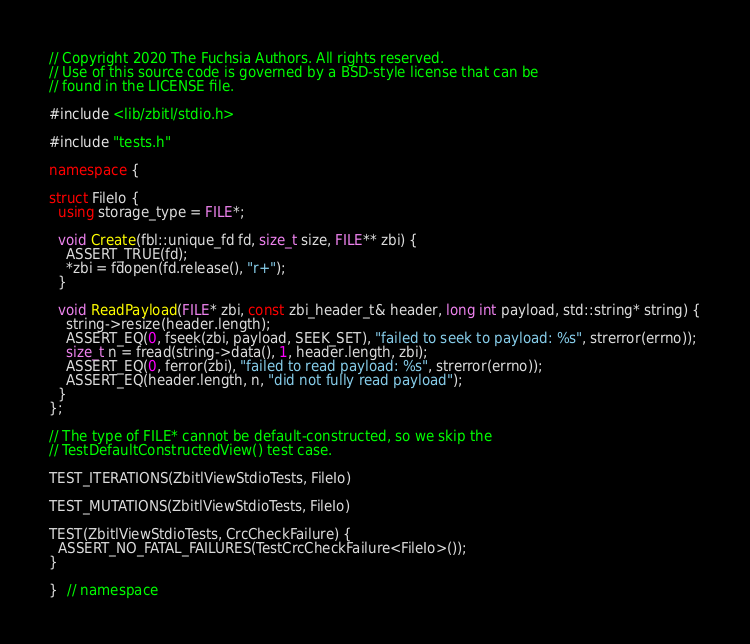<code> <loc_0><loc_0><loc_500><loc_500><_C++_>// Copyright 2020 The Fuchsia Authors. All rights reserved.
// Use of this source code is governed by a BSD-style license that can be
// found in the LICENSE file.

#include <lib/zbitl/stdio.h>

#include "tests.h"

namespace {

struct FileIo {
  using storage_type = FILE*;

  void Create(fbl::unique_fd fd, size_t size, FILE** zbi) {
    ASSERT_TRUE(fd);
    *zbi = fdopen(fd.release(), "r+");
  }

  void ReadPayload(FILE* zbi, const zbi_header_t& header, long int payload, std::string* string) {
    string->resize(header.length);
    ASSERT_EQ(0, fseek(zbi, payload, SEEK_SET), "failed to seek to payload: %s", strerror(errno));
    size_t n = fread(string->data(), 1, header.length, zbi);
    ASSERT_EQ(0, ferror(zbi), "failed to read payload: %s", strerror(errno));
    ASSERT_EQ(header.length, n, "did not fully read payload");
  }
};

// The type of FILE* cannot be default-constructed, so we skip the
// TestDefaultConstructedView() test case.

TEST_ITERATIONS(ZbitlViewStdioTests, FileIo)

TEST_MUTATIONS(ZbitlViewStdioTests, FileIo)

TEST(ZbitlViewStdioTests, CrcCheckFailure) {
  ASSERT_NO_FATAL_FAILURES(TestCrcCheckFailure<FileIo>());
}

}  // namespace
</code> 